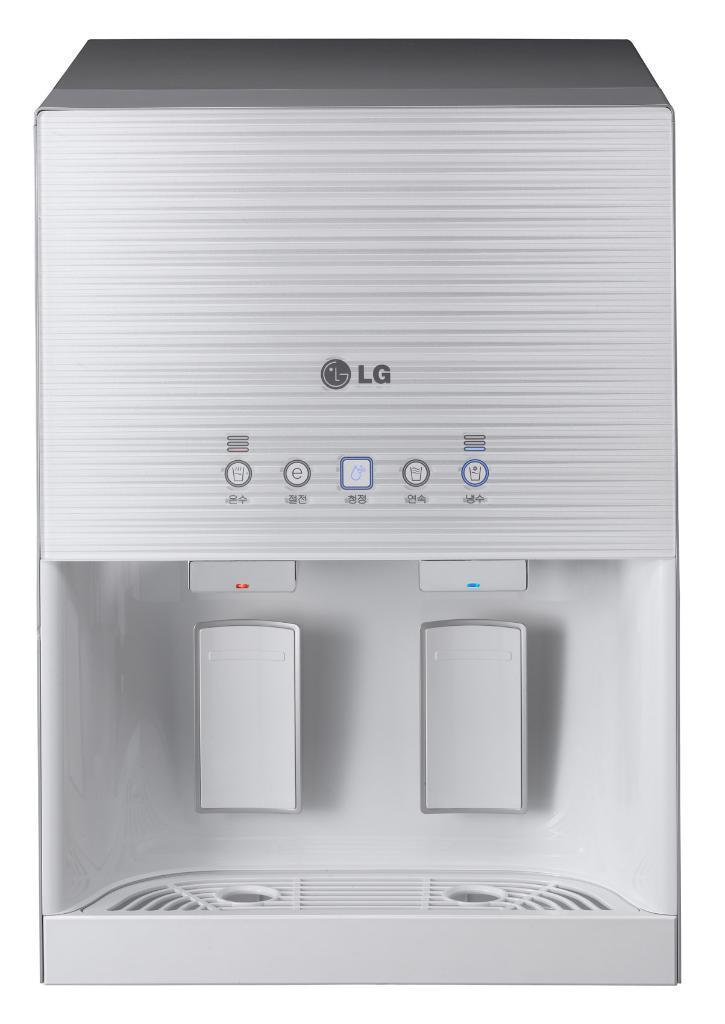In one or two sentences, can you explain what this image depicts? In this image there is a water purifier, there are buttons, there is text on the water purifier, the background of the image is white in color. 